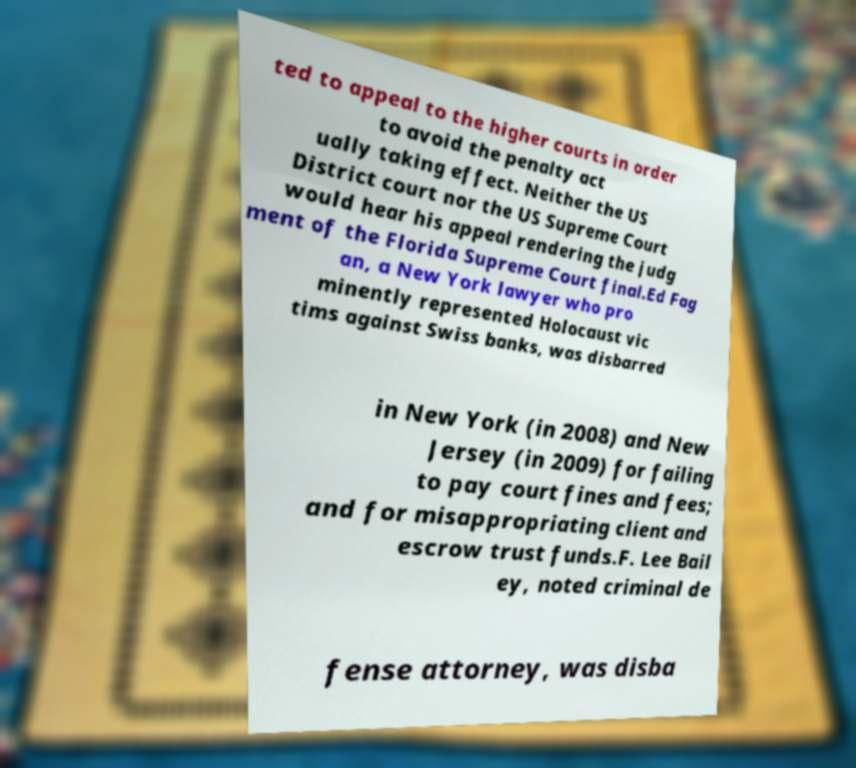For documentation purposes, I need the text within this image transcribed. Could you provide that? ted to appeal to the higher courts in order to avoid the penalty act ually taking effect. Neither the US District court nor the US Supreme Court would hear his appeal rendering the judg ment of the Florida Supreme Court final.Ed Fag an, a New York lawyer who pro minently represented Holocaust vic tims against Swiss banks, was disbarred in New York (in 2008) and New Jersey (in 2009) for failing to pay court fines and fees; and for misappropriating client and escrow trust funds.F. Lee Bail ey, noted criminal de fense attorney, was disba 